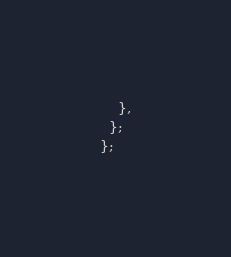<code> <loc_0><loc_0><loc_500><loc_500><_TypeScript_>    },
  };
};
</code> 